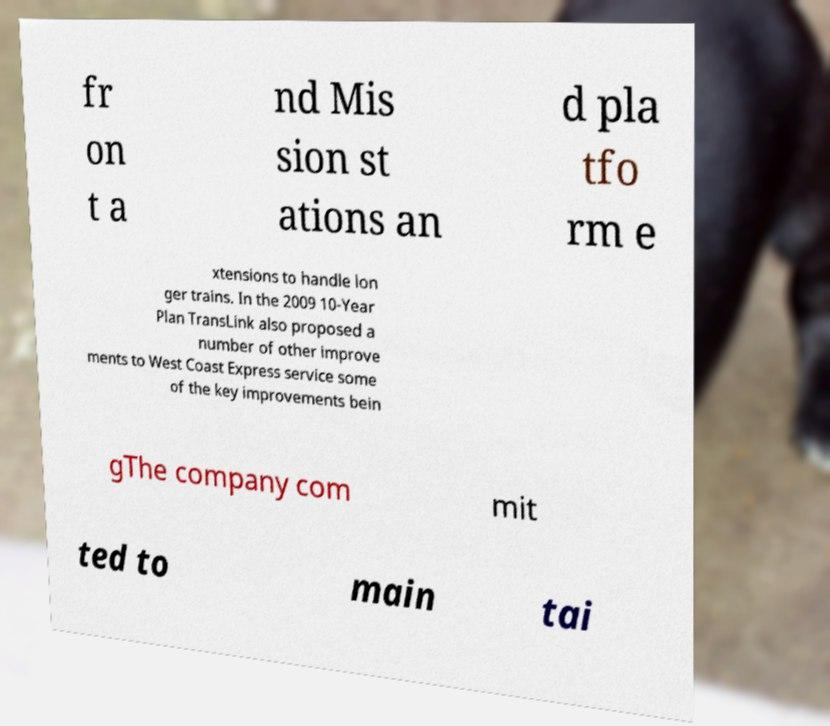Please read and relay the text visible in this image. What does it say? fr on t a nd Mis sion st ations an d pla tfo rm e xtensions to handle lon ger trains. In the 2009 10-Year Plan TransLink also proposed a number of other improve ments to West Coast Express service some of the key improvements bein gThe company com mit ted to main tai 